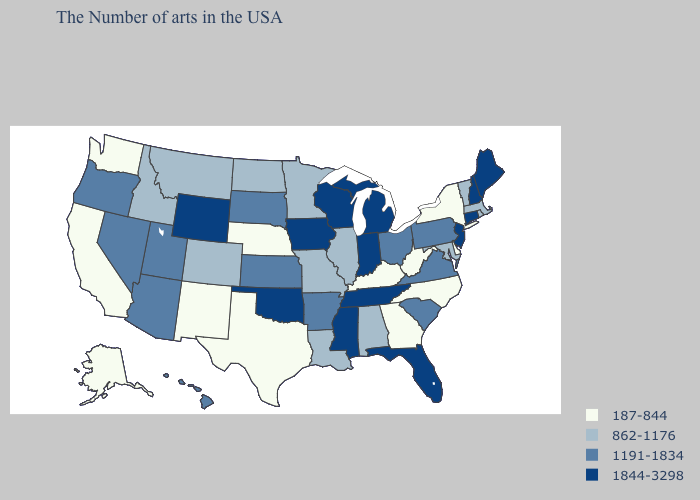Among the states that border Georgia , does Tennessee have the lowest value?
Short answer required. No. Which states have the lowest value in the West?
Answer briefly. New Mexico, California, Washington, Alaska. What is the highest value in the Northeast ?
Give a very brief answer. 1844-3298. Does the map have missing data?
Short answer required. No. What is the value of Virginia?
Quick response, please. 1191-1834. Name the states that have a value in the range 187-844?
Quick response, please. New York, Delaware, North Carolina, West Virginia, Georgia, Kentucky, Nebraska, Texas, New Mexico, California, Washington, Alaska. Does Maryland have the lowest value in the USA?
Be succinct. No. Does the first symbol in the legend represent the smallest category?
Answer briefly. Yes. Name the states that have a value in the range 862-1176?
Answer briefly. Massachusetts, Rhode Island, Vermont, Maryland, Alabama, Illinois, Louisiana, Missouri, Minnesota, North Dakota, Colorado, Montana, Idaho. What is the value of Arkansas?
Answer briefly. 1191-1834. Does California have the lowest value in the USA?
Quick response, please. Yes. What is the highest value in the Northeast ?
Keep it brief. 1844-3298. What is the value of Wyoming?
Keep it brief. 1844-3298. What is the value of Nevada?
Answer briefly. 1191-1834. What is the value of Arkansas?
Be succinct. 1191-1834. 